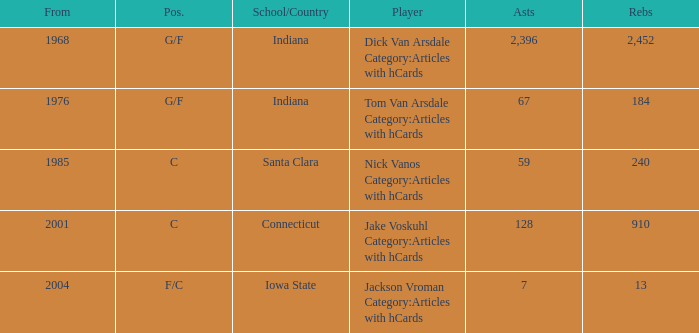What is the highest number of assists for players that are f/c and have under 13 rebounds? None. 